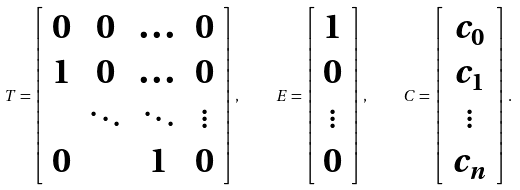<formula> <loc_0><loc_0><loc_500><loc_500>T = \left [ \begin{array} { c c c c } 0 & 0 & \dots & 0 \\ 1 & 0 & \dots & 0 \\ & \ddots & \ddots & \vdots \\ 0 & & 1 & 0 \end{array} \right ] , \quad E = \left [ \begin{array} { c } 1 \\ 0 \\ \vdots \\ 0 \end{array} \right ] , \quad C = \left [ \begin{array} { c } c _ { 0 } \\ c _ { 1 } \\ \vdots \\ c _ { n } \end{array} \right ] .</formula> 